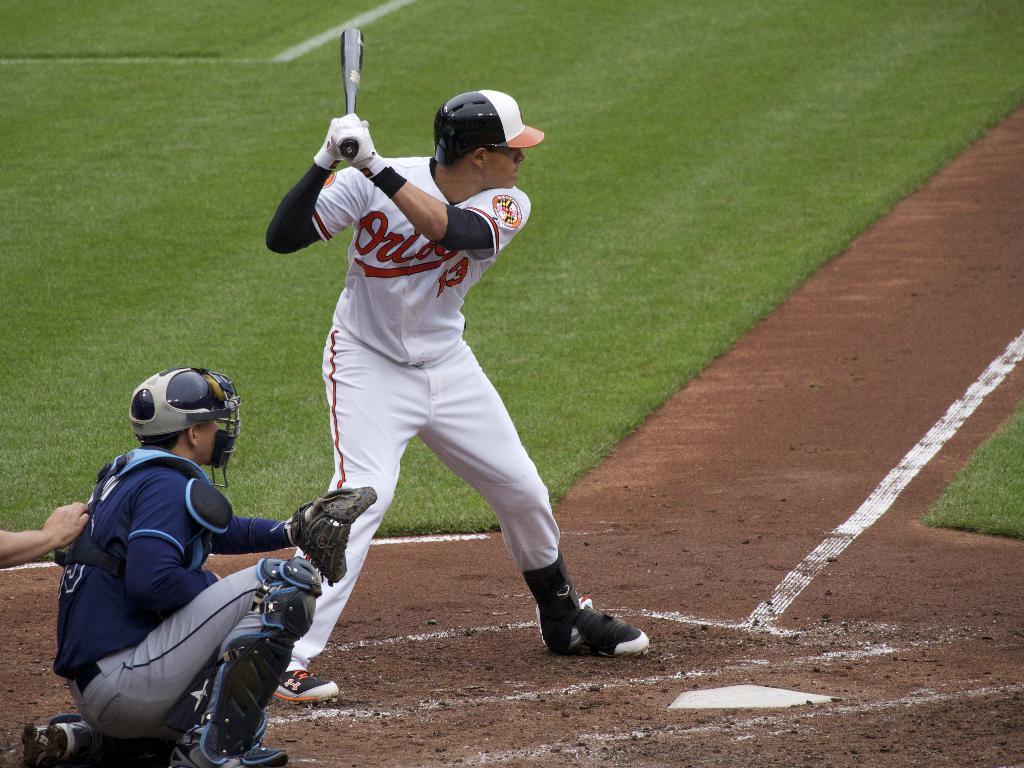What team is this person batting for?
Your answer should be very brief. Orioles. What number does the hitter wear on his jersey?
Provide a succinct answer. 13. 